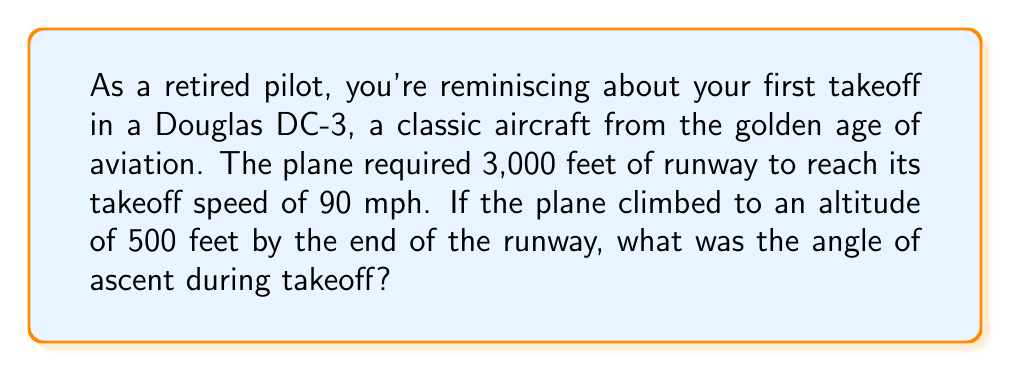Provide a solution to this math problem. Let's approach this step-by-step:

1) First, we need to visualize the problem. The plane's path forms a right triangle with the runway and its altitude at the end of the runway.

[asy]
import geometry;

size(200);
pair A=(0,0), B=(10,0), C=(10,1.67);
draw(A--B--C--A);
label("3,000 ft",B,S);
label("500 ft",C,E);
label("$\theta$",A,NE);
[/asy]

2) We know:
   - The length of the runway (base of the triangle) = 3,000 feet
   - The altitude at the end of the runway (height of the triangle) = 500 feet

3) We need to find the angle of ascent, which is the angle between the runway and the plane's path.

4) This can be solved using the tangent function:

   $$\tan(\theta) = \frac{\text{opposite}}{\text{adjacent}} = \frac{\text{altitude}}{\text{runway length}}$$

5) Plugging in our values:

   $$\tan(\theta) = \frac{500}{3000} = \frac{1}{6} \approx 0.1667$$

6) To find $\theta$, we need to use the inverse tangent (arctan or $\tan^{-1}$):

   $$\theta = \tan^{-1}(\frac{1}{6})$$

7) Using a calculator or trigonometric tables:

   $$\theta \approx 9.46^\circ$$

Therefore, the angle of ascent during takeoff was approximately 9.46 degrees.
Answer: $9.46^\circ$ 